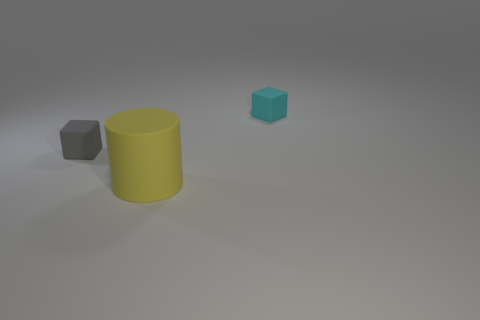Add 1 cyan objects. How many objects exist? 4 Subtract all cubes. How many objects are left? 1 Add 2 cyan objects. How many cyan objects exist? 3 Subtract 0 brown cubes. How many objects are left? 3 Subtract all tiny rubber blocks. Subtract all gray things. How many objects are left? 0 Add 3 blocks. How many blocks are left? 5 